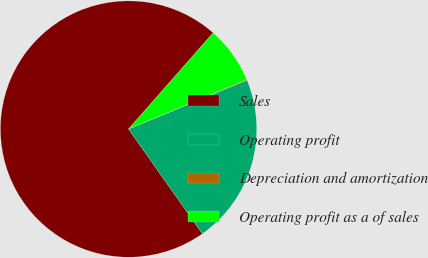Convert chart. <chart><loc_0><loc_0><loc_500><loc_500><pie_chart><fcel>Sales<fcel>Operating profit<fcel>Depreciation and amortization<fcel>Operating profit as a of sales<nl><fcel>71.25%<fcel>21.44%<fcel>0.1%<fcel>7.21%<nl></chart> 